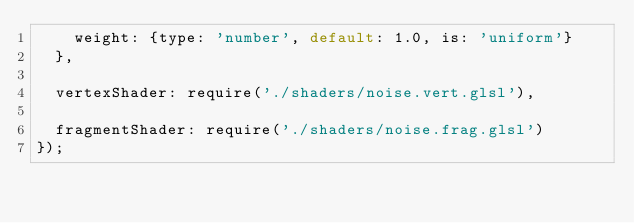Convert code to text. <code><loc_0><loc_0><loc_500><loc_500><_JavaScript_>    weight: {type: 'number', default: 1.0, is: 'uniform'}
  },

  vertexShader: require('./shaders/noise.vert.glsl'),

  fragmentShader: require('./shaders/noise.frag.glsl')
});
</code> 